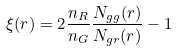<formula> <loc_0><loc_0><loc_500><loc_500>\xi ( r ) = 2 \frac { n _ { R } } { n _ { G } } \frac { N _ { g g } ( r ) } { N _ { g r } ( r ) } - 1</formula> 